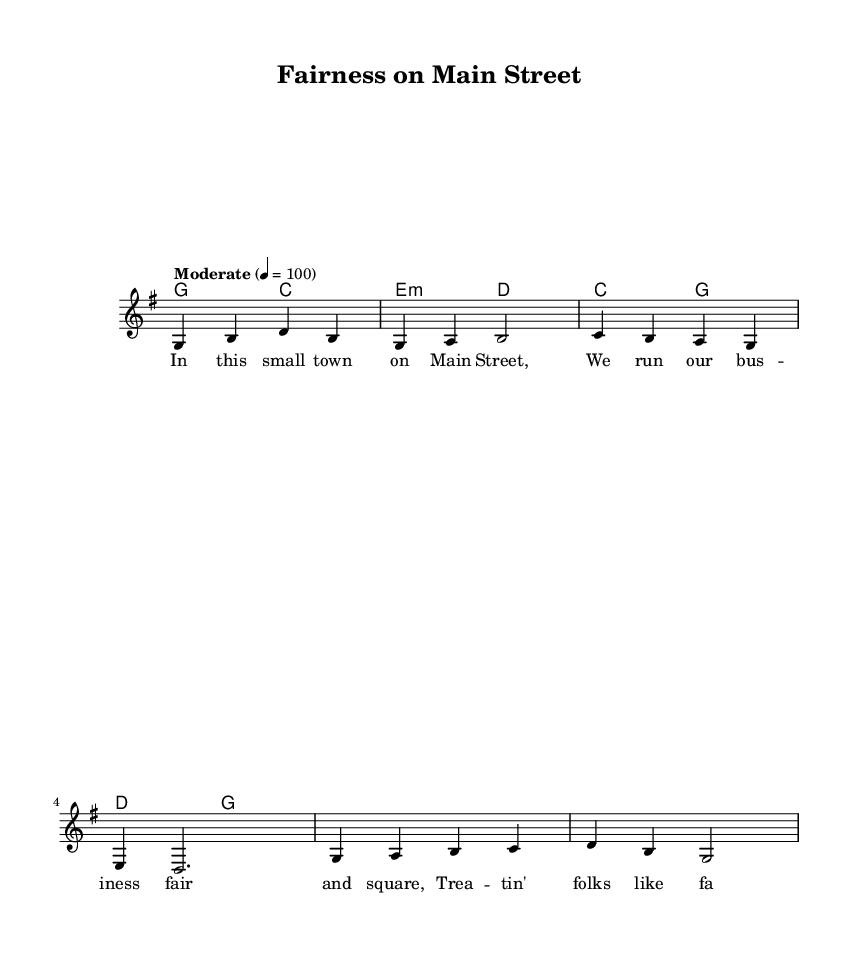What is the key signature of this music? The key signature is G major, which has one sharp (F#). This is indicated at the beginning of the staff where key signatures are notated.
Answer: G major What is the time signature of the piece? The time signature is 4/4, which is indicated at the beginning of the score. This means there are four beats in each measure and the quarter note gets one beat.
Answer: 4/4 What is the tempo of this song? The tempo is indicated as "Moderate" with a metronome marking of 100 beats per minute. This provides a guideline on how fast the song should be played.
Answer: Moderately, 100 How many measures are in the verse? The verse consists of four measures, as shown in the marked section with four lines of music that each contain one measure.
Answer: 4 What is the main theme of the lyrics? The main theme revolves around fairness, respect, and community within a business context, illustrated through lyrics focusing on treating employees and customers well.
Answer: Fairness and respect What chords are used in the chorus? The chorus uses the chords C major and G major, followed by D major and G major, as indicated in the chord progression above the staff for the chorus section.
Answer: C, G, D What is the overall message conveyed in the song? The overall message promotes ethical business practices such as respect and appreciation for employees and community, which is paramount for building trust.
Answer: Ethical practices and appreciation 